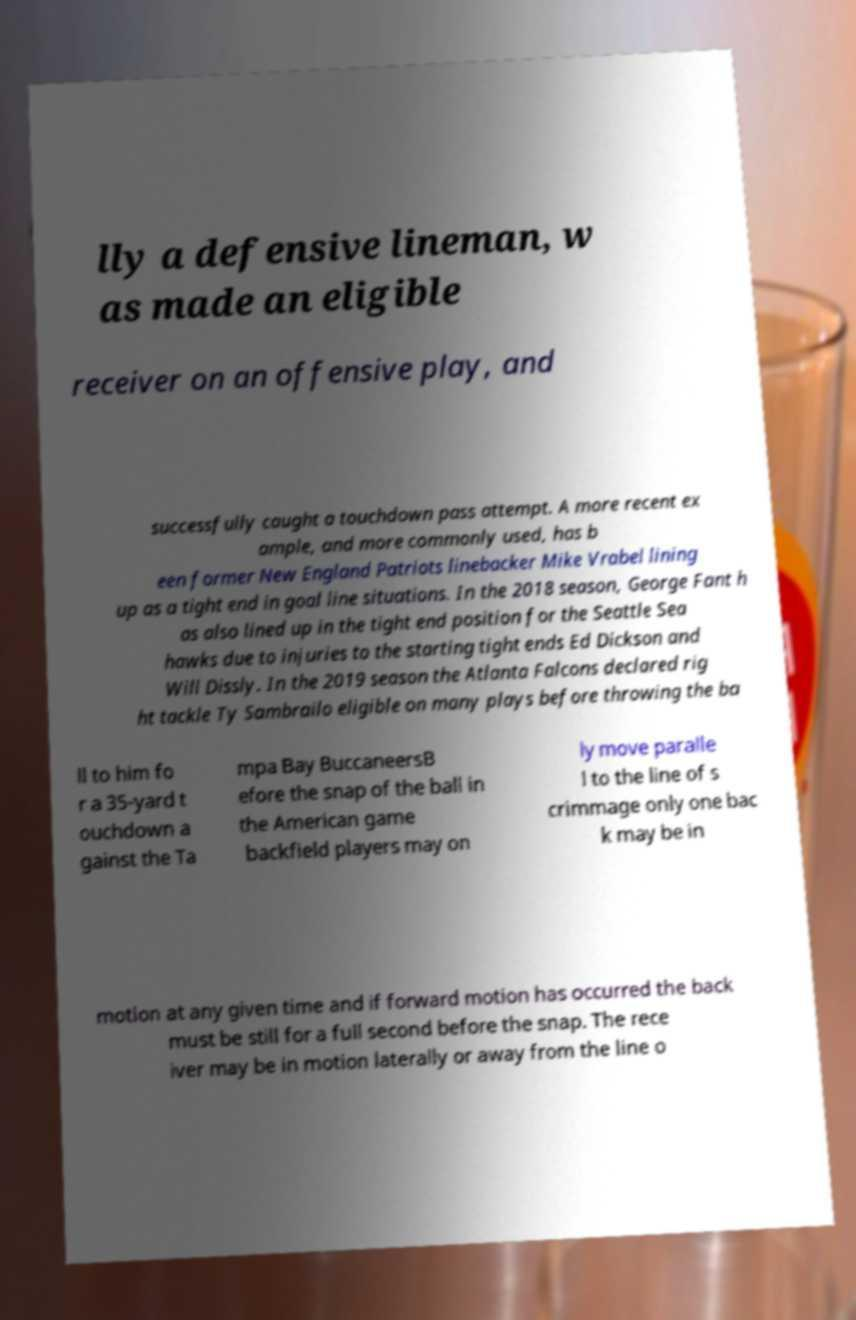Please identify and transcribe the text found in this image. lly a defensive lineman, w as made an eligible receiver on an offensive play, and successfully caught a touchdown pass attempt. A more recent ex ample, and more commonly used, has b een former New England Patriots linebacker Mike Vrabel lining up as a tight end in goal line situations. In the 2018 season, George Fant h as also lined up in the tight end position for the Seattle Sea hawks due to injuries to the starting tight ends Ed Dickson and Will Dissly. In the 2019 season the Atlanta Falcons declared rig ht tackle Ty Sambrailo eligible on many plays before throwing the ba ll to him fo r a 35-yard t ouchdown a gainst the Ta mpa Bay BuccaneersB efore the snap of the ball in the American game backfield players may on ly move paralle l to the line of s crimmage only one bac k may be in motion at any given time and if forward motion has occurred the back must be still for a full second before the snap. The rece iver may be in motion laterally or away from the line o 